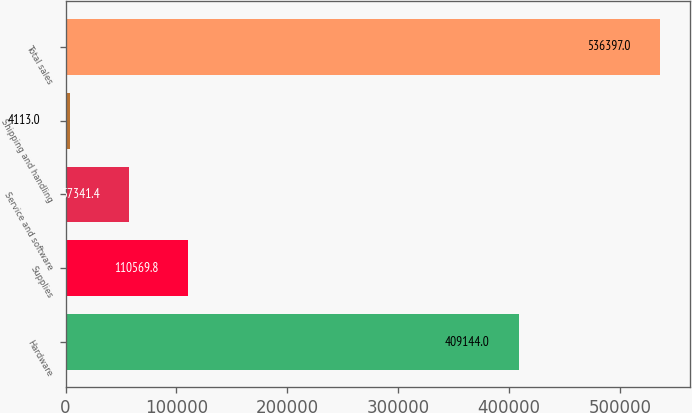<chart> <loc_0><loc_0><loc_500><loc_500><bar_chart><fcel>Hardware<fcel>Supplies<fcel>Service and software<fcel>Shipping and handling<fcel>Total sales<nl><fcel>409144<fcel>110570<fcel>57341.4<fcel>4113<fcel>536397<nl></chart> 